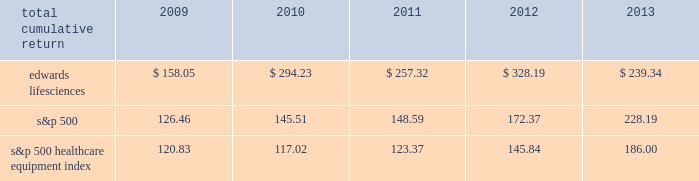25feb201400255845 performance graph the following graph compares the performance of our common stock with that of the s&p 500 index and the s&p 500 healthcare equipment index .
The cumulative total return listed below assumes an initial investment of $ 100 on december 31 , 2008 and reinvestment of dividends .
Comparison of five year cumulative total return 2008 2009 2010 2011 20132012 edwards lifesciences s&p 500 s&p 500 healthcare equipment december 31 .

What was the cumulative percentage return for five year period ended 2013? 
Computations: ((239.34 - 100) / 100)
Answer: 1.3934. 